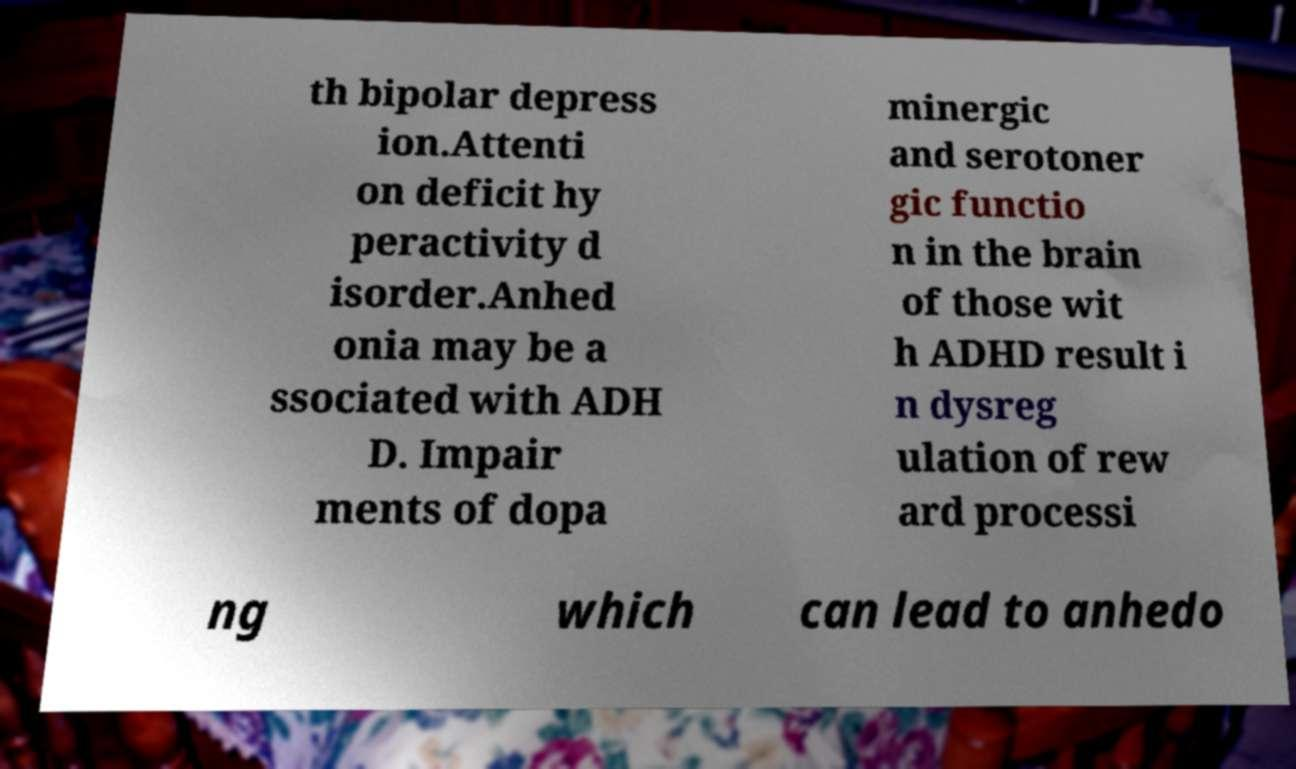There's text embedded in this image that I need extracted. Can you transcribe it verbatim? th bipolar depress ion.Attenti on deficit hy peractivity d isorder.Anhed onia may be a ssociated with ADH D. Impair ments of dopa minergic and serotoner gic functio n in the brain of those wit h ADHD result i n dysreg ulation of rew ard processi ng which can lead to anhedo 